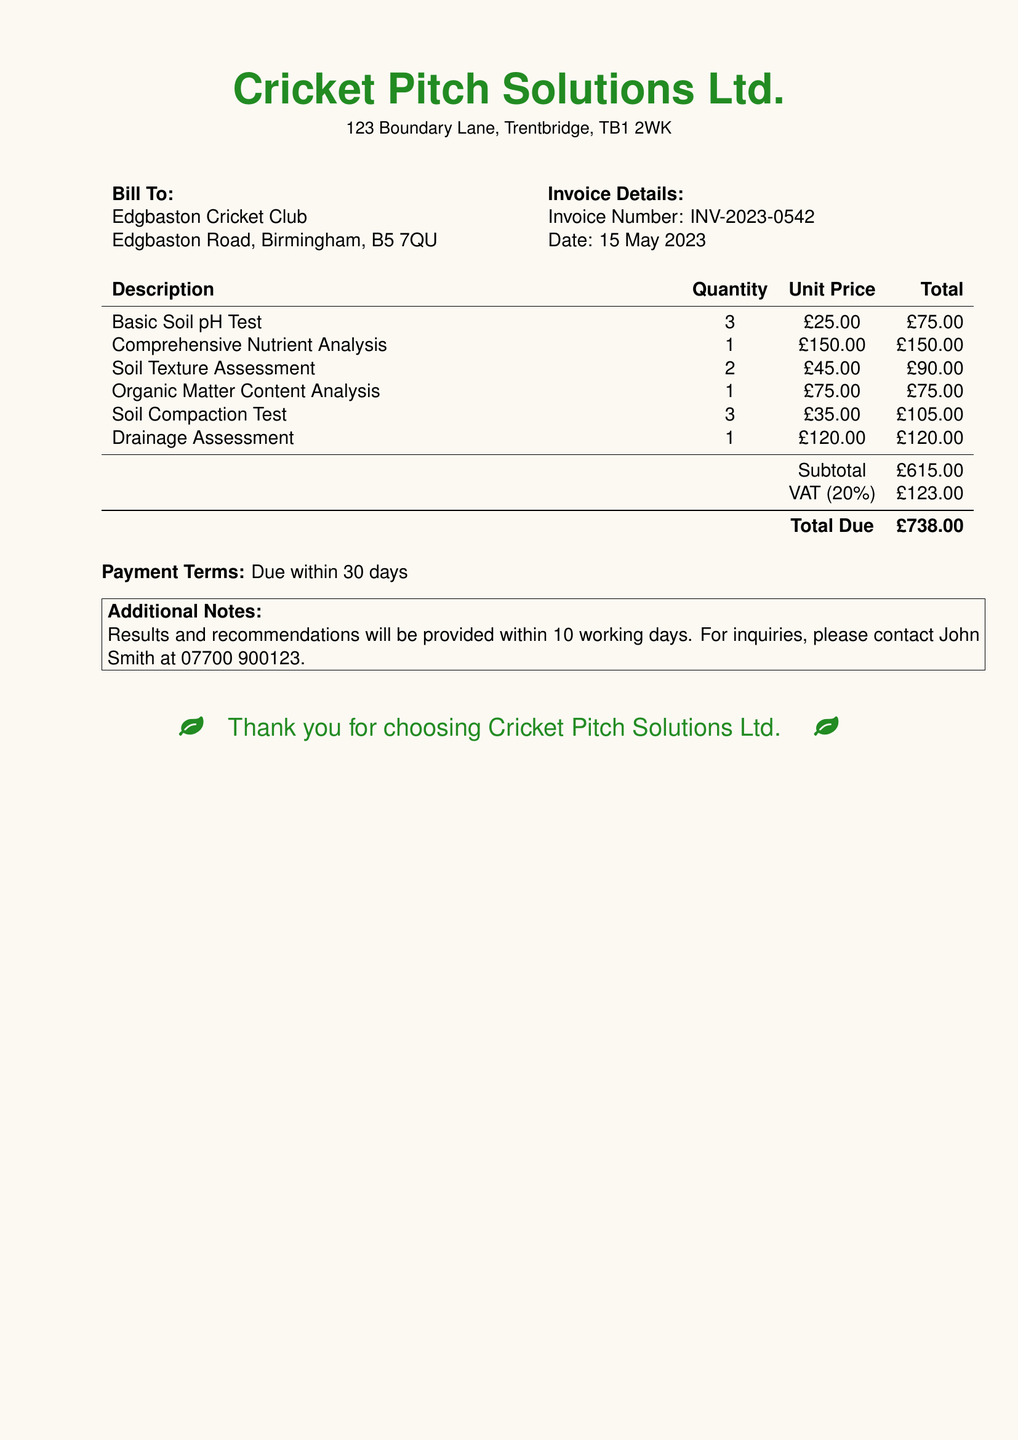What is the invoice number? The invoice number is clearly stated in the document; it identifies the specific transaction.
Answer: INV-2023-0542 What is the total due amount? The total due is calculated by adding the subtotal and VAT as shown in the document.
Answer: £738.00 Who is the contact person for inquiries? The document specifies a contact for any inquiries regarding the bill.
Answer: John Smith What is the quantity of Basic Soil pH Tests conducted? The quantity reflects how many of that specific test were performed as detailed in the bill.
Answer: 3 What is the VAT percentage applied? The document lists the VAT percentage that is applied to the total amount due.
Answer: 20% What is the subtotal amount before VAT? The subtotal represents the total of all service charges before VAT is added, as shown in the document.
Answer: £615.00 When is the payment due? The bill mentions the payment terms, indicating how long the client has to settle the payment.
Answer: Due within 30 days How many Soil Compaction Tests were conducted? The document details the number of each test performed, specifically for Soil Compaction Tests.
Answer: 3 What is the price for a Comprehensive Nutrient Analysis? The unit price for the Comprehensive Nutrient Analysis indicates how much is charged for that service.
Answer: £150.00 